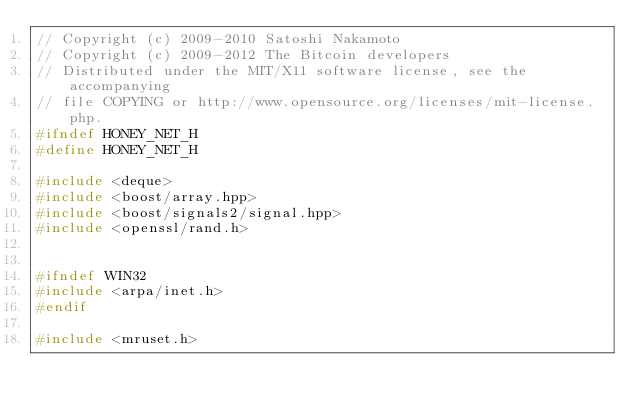Convert code to text. <code><loc_0><loc_0><loc_500><loc_500><_C_>// Copyright (c) 2009-2010 Satoshi Nakamoto
// Copyright (c) 2009-2012 The Bitcoin developers
// Distributed under the MIT/X11 software license, see the accompanying
// file COPYING or http://www.opensource.org/licenses/mit-license.php.
#ifndef HONEY_NET_H
#define HONEY_NET_H

#include <deque>
#include <boost/array.hpp>
#include <boost/signals2/signal.hpp>
#include <openssl/rand.h>


#ifndef WIN32
#include <arpa/inet.h>
#endif

#include <mruset.h></code> 